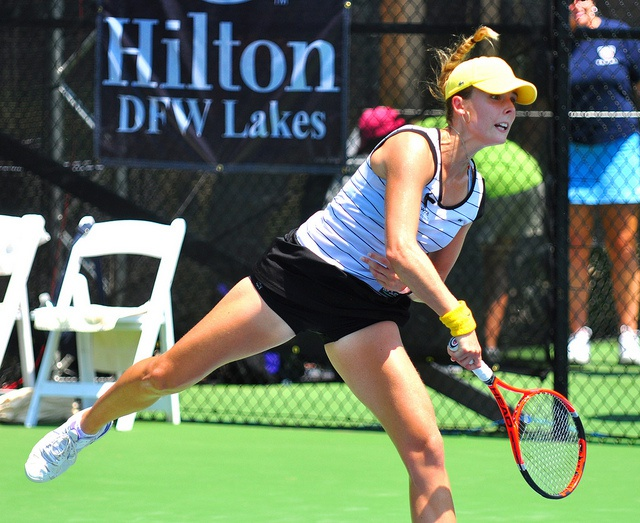Describe the objects in this image and their specific colors. I can see people in black, brown, ivory, and tan tones, people in black, blue, navy, and white tones, chair in black, white, darkgray, and lightblue tones, people in black, lightgreen, gray, and darkgreen tones, and tennis racket in black, lightgreen, and red tones in this image. 